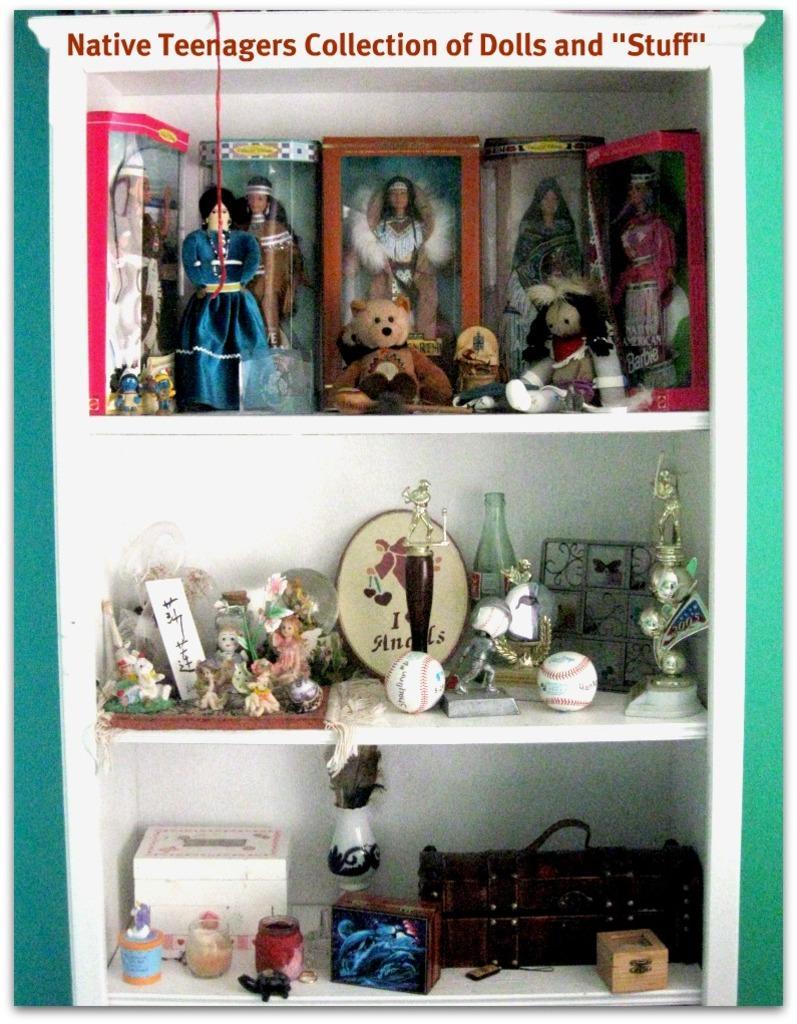Please provide a concise description of this image. In this image we can see some toys, objects, show pieces, awards, boxes and some other items which are arranged in shelves and top of the image there is some text written. 